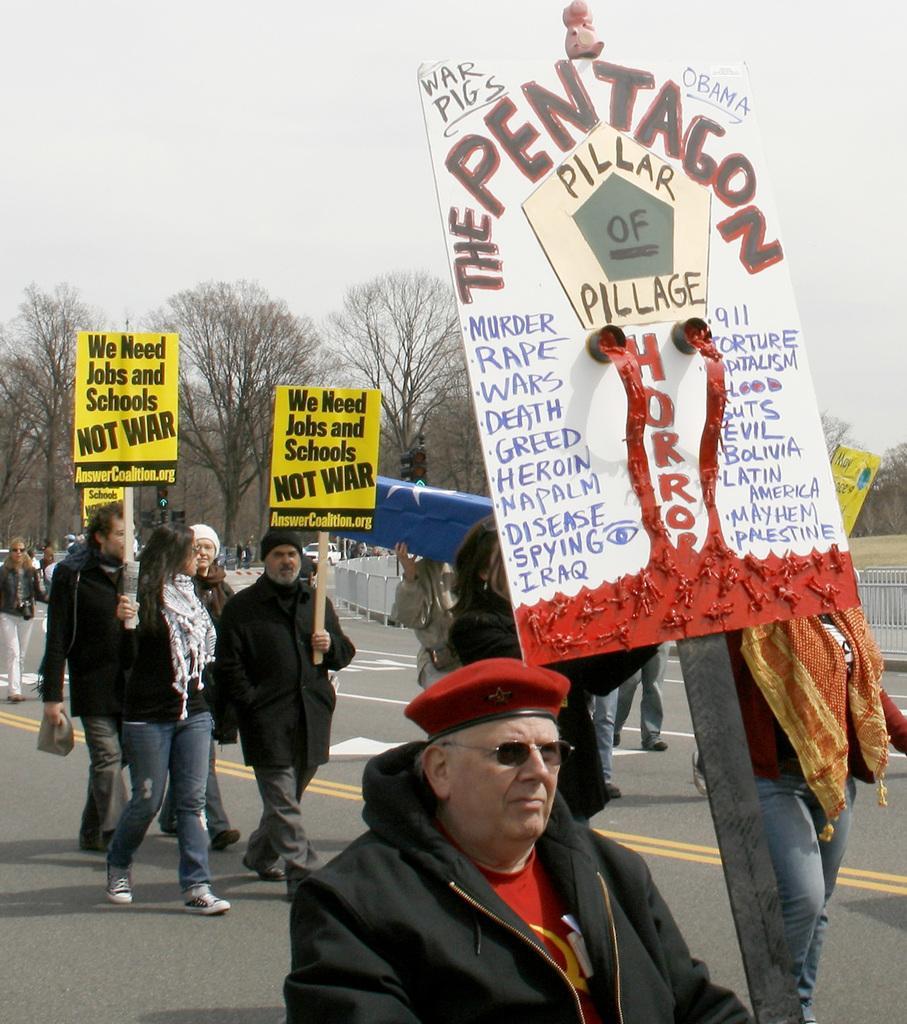Describe this image in one or two sentences. In this image I can see people on the road. These people are holding placards. In the background I can see fence, trees and the sky. 